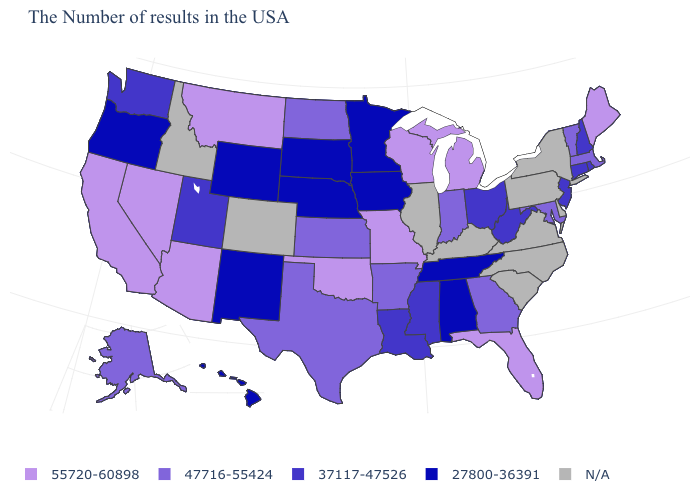Name the states that have a value in the range N/A?
Give a very brief answer. New York, Delaware, Pennsylvania, Virginia, North Carolina, South Carolina, Kentucky, Illinois, Colorado, Idaho. What is the value of Arizona?
Short answer required. 55720-60898. Which states have the lowest value in the USA?
Concise answer only. Alabama, Tennessee, Minnesota, Iowa, Nebraska, South Dakota, Wyoming, New Mexico, Oregon, Hawaii. What is the value of New York?
Answer briefly. N/A. Name the states that have a value in the range 55720-60898?
Be succinct. Maine, Florida, Michigan, Wisconsin, Missouri, Oklahoma, Montana, Arizona, Nevada, California. What is the value of Iowa?
Short answer required. 27800-36391. Name the states that have a value in the range N/A?
Concise answer only. New York, Delaware, Pennsylvania, Virginia, North Carolina, South Carolina, Kentucky, Illinois, Colorado, Idaho. What is the highest value in the USA?
Be succinct. 55720-60898. Name the states that have a value in the range N/A?
Answer briefly. New York, Delaware, Pennsylvania, Virginia, North Carolina, South Carolina, Kentucky, Illinois, Colorado, Idaho. Does Wyoming have the lowest value in the West?
Be succinct. Yes. Among the states that border California , which have the highest value?
Be succinct. Arizona, Nevada. Does Missouri have the highest value in the USA?
Answer briefly. Yes. Name the states that have a value in the range 47716-55424?
Write a very short answer. Massachusetts, Vermont, Maryland, Georgia, Indiana, Arkansas, Kansas, Texas, North Dakota, Alaska. What is the value of New Mexico?
Answer briefly. 27800-36391. 